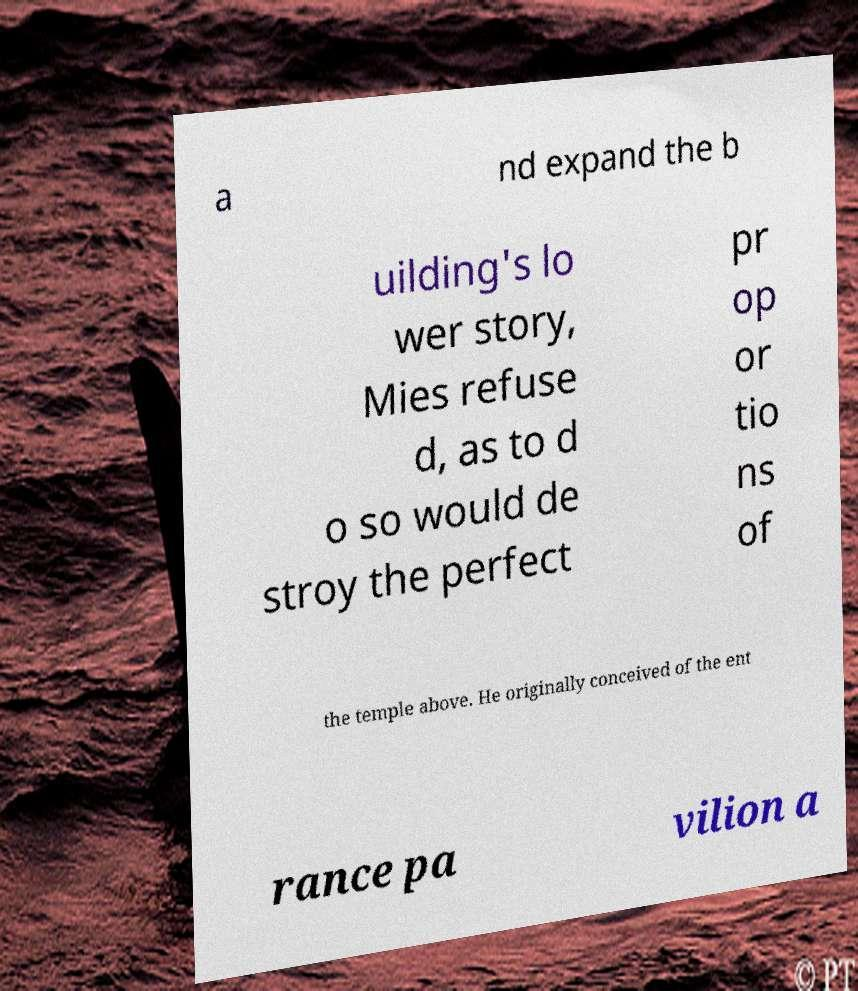Could you extract and type out the text from this image? a nd expand the b uilding's lo wer story, Mies refuse d, as to d o so would de stroy the perfect pr op or tio ns of the temple above. He originally conceived of the ent rance pa vilion a 